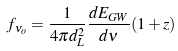Convert formula to latex. <formula><loc_0><loc_0><loc_500><loc_500>f _ { \nu _ { o } } = \frac { 1 } { 4 \pi d _ { L } ^ { 2 } } \frac { d E _ { G W } } { d \nu } ( 1 + z )</formula> 